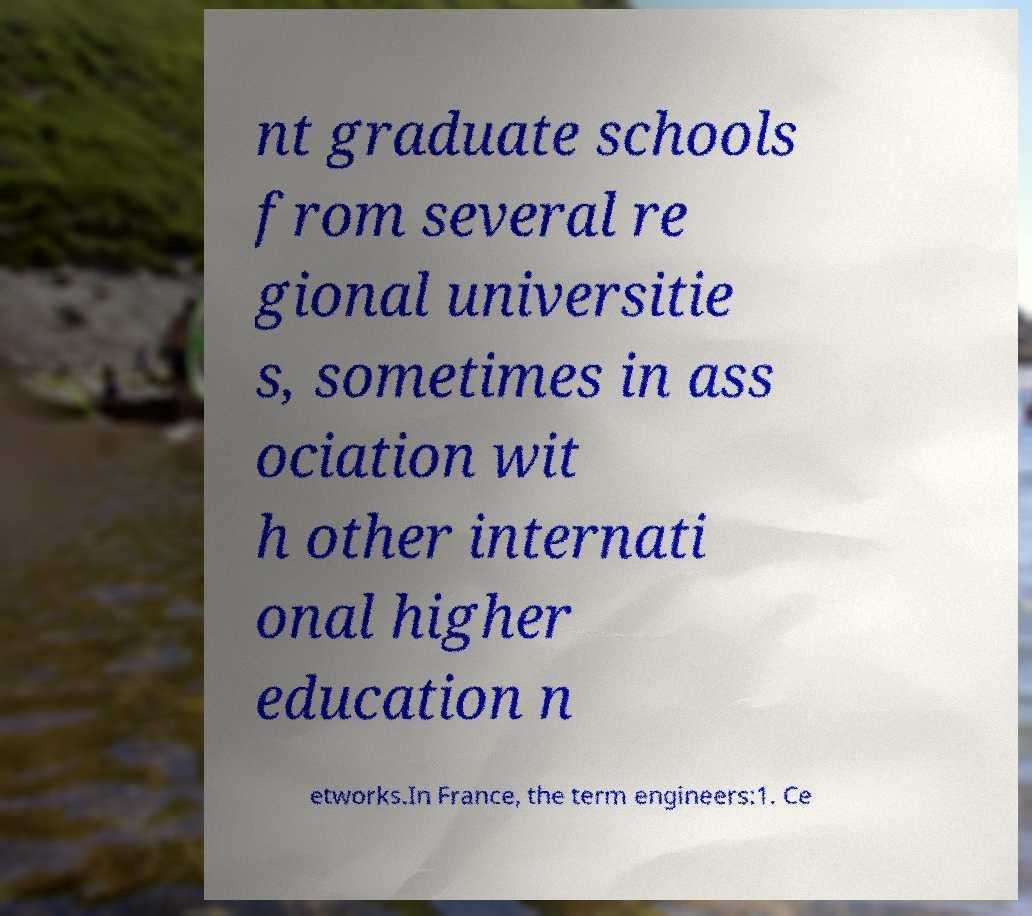Can you accurately transcribe the text from the provided image for me? nt graduate schools from several re gional universitie s, sometimes in ass ociation wit h other internati onal higher education n etworks.In France, the term engineers:1. Ce 